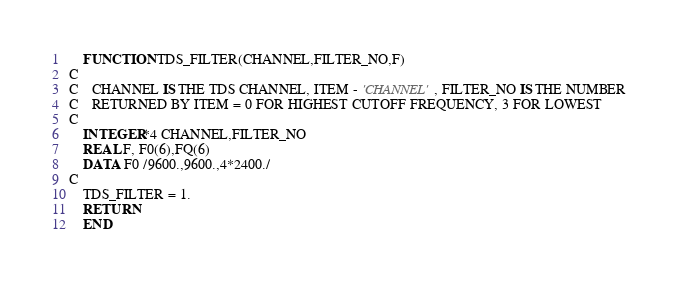Convert code to text. <code><loc_0><loc_0><loc_500><loc_500><_FORTRAN_>	FUNCTION TDS_FILTER(CHANNEL,FILTER_NO,F)
C
C	CHANNEL IS THE TDS CHANNEL, ITEM - 'CHANNEL', FILTER_NO IS THE NUMBER 
C	RETURNED BY ITEM = 0 FOR HIGHEST CUTOFF FREQUENCY, 3 FOR LOWEST
C
	INTEGER*4 CHANNEL,FILTER_NO
	REAL F, F0(6),FQ(6)
	DATA F0 /9600.,9600.,4*2400./
C
	TDS_FILTER = 1.
	RETURN
	END
</code> 